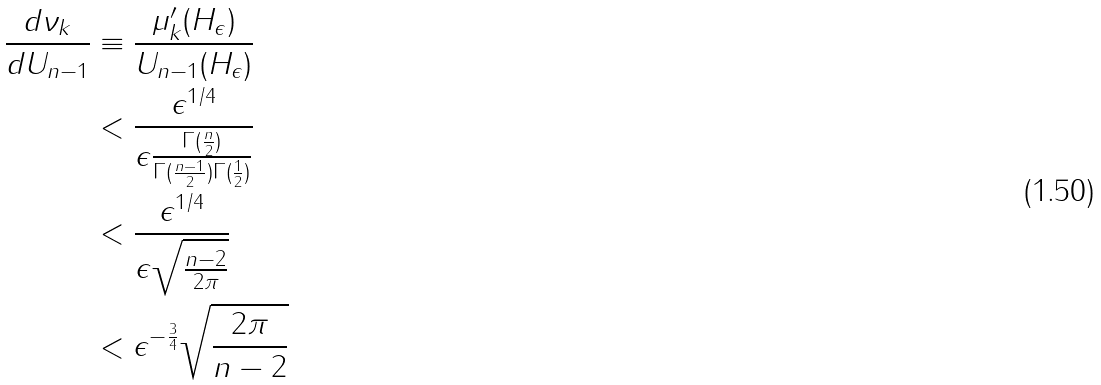Convert formula to latex. <formula><loc_0><loc_0><loc_500><loc_500>\frac { d \nu _ { k } } { d U _ { n - 1 } } & \equiv \frac { \mu ^ { \prime } _ { k } ( H _ { \epsilon } ) } { U _ { n - 1 } ( H _ { \epsilon } ) } \\ & < \frac { \epsilon ^ { 1 / 4 } } { \epsilon \frac { \Gamma ( \frac { n } { 2 } ) } { \Gamma ( \frac { n - 1 } { 2 } ) \Gamma ( \frac { 1 } { 2 } ) } } \\ & < \frac { \epsilon ^ { 1 / 4 } } { \epsilon \sqrt { \frac { n - 2 } { 2 \pi } } } \\ & < \epsilon ^ { - \frac { 3 } { 4 } } \sqrt { \frac { 2 \pi } { n - 2 } }</formula> 